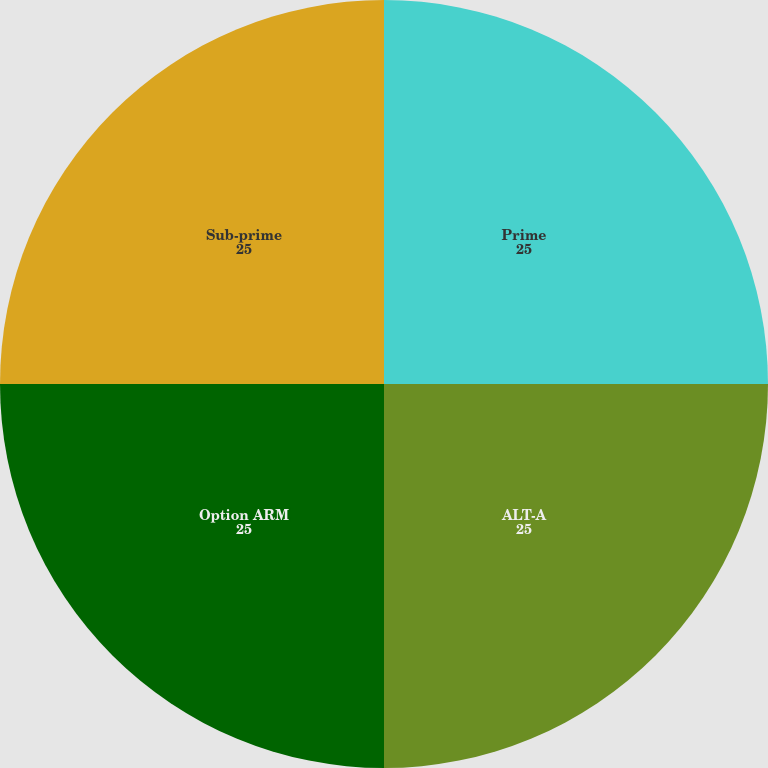Convert chart to OTSL. <chart><loc_0><loc_0><loc_500><loc_500><pie_chart><fcel>Prime<fcel>ALT-A<fcel>Option ARM<fcel>Sub-prime<nl><fcel>25.0%<fcel>25.0%<fcel>25.0%<fcel>25.0%<nl></chart> 